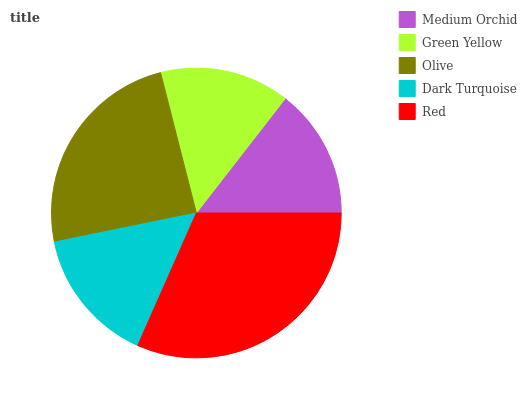Is Green Yellow the minimum?
Answer yes or no. Yes. Is Red the maximum?
Answer yes or no. Yes. Is Olive the minimum?
Answer yes or no. No. Is Olive the maximum?
Answer yes or no. No. Is Olive greater than Green Yellow?
Answer yes or no. Yes. Is Green Yellow less than Olive?
Answer yes or no. Yes. Is Green Yellow greater than Olive?
Answer yes or no. No. Is Olive less than Green Yellow?
Answer yes or no. No. Is Dark Turquoise the high median?
Answer yes or no. Yes. Is Dark Turquoise the low median?
Answer yes or no. Yes. Is Red the high median?
Answer yes or no. No. Is Red the low median?
Answer yes or no. No. 